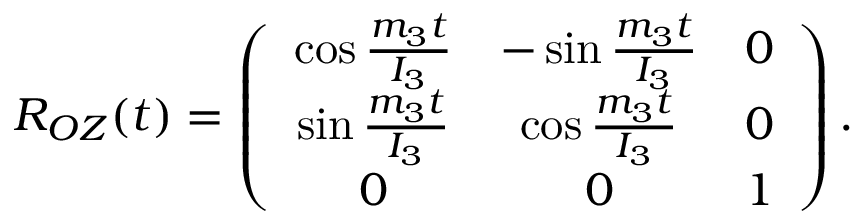Convert formula to latex. <formula><loc_0><loc_0><loc_500><loc_500>\begin{array} { r } { R _ { O Z } ( t ) = \left ( \begin{array} { c c c } { \cos \frac { m _ { 3 } t } { I _ { 3 } } } & { - \sin \frac { m _ { 3 } t } { I _ { 3 } } } & { 0 } \\ { \sin \frac { m _ { 3 } t } { I _ { 3 } } } & { \cos \frac { m _ { 3 } t } { I _ { 3 } } } & { 0 } \\ { 0 } & { 0 } & { 1 } \end{array} \right ) . } \end{array}</formula> 